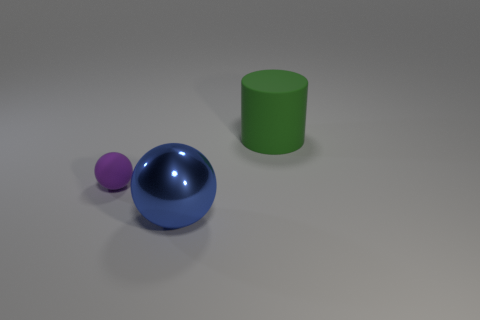Are there more large rubber things that are in front of the blue sphere than blue shiny objects behind the large rubber cylinder?
Ensure brevity in your answer.  No. What material is the blue object that is the same size as the green cylinder?
Give a very brief answer. Metal. What number of tiny objects are either matte things or brown things?
Your answer should be very brief. 1. Does the shiny thing have the same shape as the tiny purple thing?
Give a very brief answer. Yes. What number of large things are both behind the large sphere and on the left side of the matte cylinder?
Keep it short and to the point. 0. Is there anything else that has the same color as the large ball?
Your response must be concise. No. There is a tiny object that is the same material as the cylinder; what is its shape?
Keep it short and to the point. Sphere. Do the rubber sphere and the green cylinder have the same size?
Offer a terse response. No. Is the material of the big object on the left side of the cylinder the same as the green cylinder?
Make the answer very short. No. Are there any other things that have the same material as the small purple object?
Your response must be concise. Yes. 